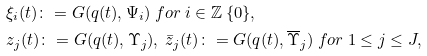Convert formula to latex. <formula><loc_0><loc_0><loc_500><loc_500>& \xi _ { i } ( t ) \colon = G ( q ( t ) , \Psi _ { i } ) \ f o r \ i \in \mathbb { Z } \ \{ 0 \} , \\ & z _ { j } ( t ) \colon = G ( q ( t ) , \Upsilon _ { j } ) , \ \bar { z } _ { j } ( t ) \colon = G ( q ( t ) , \overline { \Upsilon } _ { j } ) \ f o r \ 1 \leq j \leq J ,</formula> 